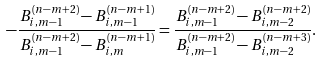<formula> <loc_0><loc_0><loc_500><loc_500>- \frac { B _ { i , m - 1 } ^ { ( n - m + 2 ) } - B _ { i , m - 1 } ^ { ( n - m + 1 ) } } { B _ { i , m - 1 } ^ { ( n - m + 2 ) } - B _ { i , m } ^ { ( n - m + 1 ) } } = \frac { B _ { i , m - 1 } ^ { ( n - m + 2 ) } - B _ { i , m - 2 } ^ { ( n - m + 2 ) } } { B _ { i , m - 1 } ^ { ( n - m + 2 ) } - B _ { i , m - 2 } ^ { ( n - m + 3 ) } } .</formula> 